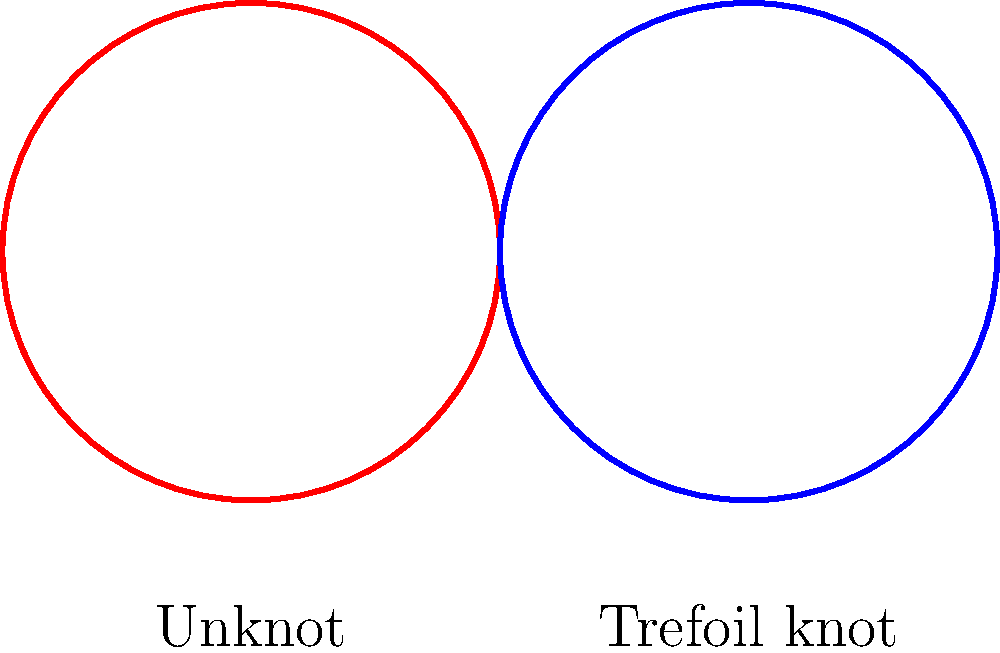In DNA topology, the linking number (Lk) is an important invariant that can be expressed as the sum of twist (Tw) and writhe (Wr). Given that a circular DNA molecule has a linking number of 5 and a twist of 3, what is its writhe? How might this relate to the trefoil knot shown in the diagram, which is often observed in DNA supercoiling? To solve this problem, let's follow these steps:

1. Recall the fundamental equation in DNA topology:
   $$ Lk = Tw + Wr $$
   Where Lk is the linking number, Tw is the twist, and Wr is the writhe.

2. We are given:
   $$ Lk = 5 $$
   $$ Tw = 3 $$

3. Substitute these values into the equation:
   $$ 5 = 3 + Wr $$

4. Solve for Wr:
   $$ Wr = 5 - 3 = 2 $$

5. The writhe (Wr) is 2.

6. Relating to the trefoil knot:
   - The trefoil knot, shown in blue in the diagram, is the simplest non-trivial knot.
   - In DNA supercoiling, the trefoil knot can form when the DNA molecule becomes highly twisted.
   - The writhe of 2 indicates a significant degree of supercoiling, which could potentially lead to the formation of knot-like structures such as the trefoil knot.
   - In aerospace engineering, similar topological concepts are applied in the study of fluid dynamics and vortex structures.

7. The unknot (shown in red) represents the relaxed circular DNA state, while the trefoil knot represents a more complex topological state that can occur due to supercoiling.
Answer: Writhe (Wr) = 2 